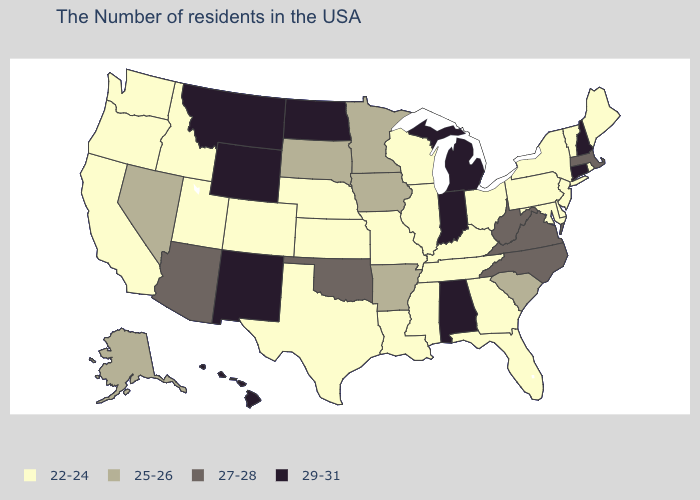Does Iowa have the lowest value in the MidWest?
Keep it brief. No. Does the map have missing data?
Concise answer only. No. What is the value of Nevada?
Give a very brief answer. 25-26. What is the value of Virginia?
Be succinct. 27-28. Does Tennessee have the lowest value in the USA?
Answer briefly. Yes. How many symbols are there in the legend?
Quick response, please. 4. How many symbols are there in the legend?
Quick response, please. 4. Is the legend a continuous bar?
Write a very short answer. No. What is the highest value in the USA?
Quick response, please. 29-31. How many symbols are there in the legend?
Give a very brief answer. 4. Which states have the lowest value in the USA?
Keep it brief. Maine, Rhode Island, Vermont, New York, New Jersey, Delaware, Maryland, Pennsylvania, Ohio, Florida, Georgia, Kentucky, Tennessee, Wisconsin, Illinois, Mississippi, Louisiana, Missouri, Kansas, Nebraska, Texas, Colorado, Utah, Idaho, California, Washington, Oregon. What is the value of Alabama?
Give a very brief answer. 29-31. Name the states that have a value in the range 29-31?
Keep it brief. New Hampshire, Connecticut, Michigan, Indiana, Alabama, North Dakota, Wyoming, New Mexico, Montana, Hawaii. What is the highest value in states that border Maine?
Short answer required. 29-31. Name the states that have a value in the range 22-24?
Quick response, please. Maine, Rhode Island, Vermont, New York, New Jersey, Delaware, Maryland, Pennsylvania, Ohio, Florida, Georgia, Kentucky, Tennessee, Wisconsin, Illinois, Mississippi, Louisiana, Missouri, Kansas, Nebraska, Texas, Colorado, Utah, Idaho, California, Washington, Oregon. 